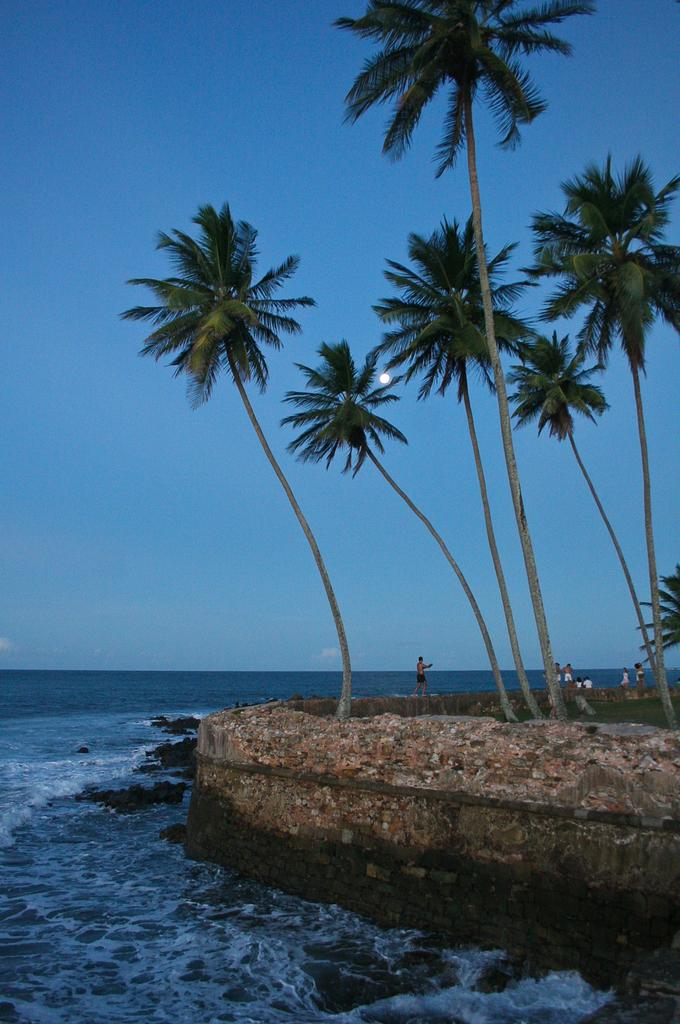What is one of the natural elements visible in the image? Water is visible in the image. What type of surface can be seen in the image? There is ground visible in the image. What type of vegetation is present in the image? There are trees in the image. Who or what is present in the image? There are people in the image. What can be seen in the background of the image? The sky and the moon are visible in the background of the image. What type of bead is being used to measure the wealth of the people in the image? There is no bead present in the image, nor is there any indication of measuring wealth. 